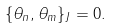<formula> <loc_0><loc_0><loc_500><loc_500>\{ \theta _ { n } , \theta _ { m } \} _ { J } = 0 .</formula> 